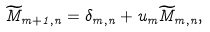Convert formula to latex. <formula><loc_0><loc_0><loc_500><loc_500>\widetilde { M } _ { m + 1 , n } = \delta _ { m , n } + u _ { m } \widetilde { M } _ { m , n } ,</formula> 